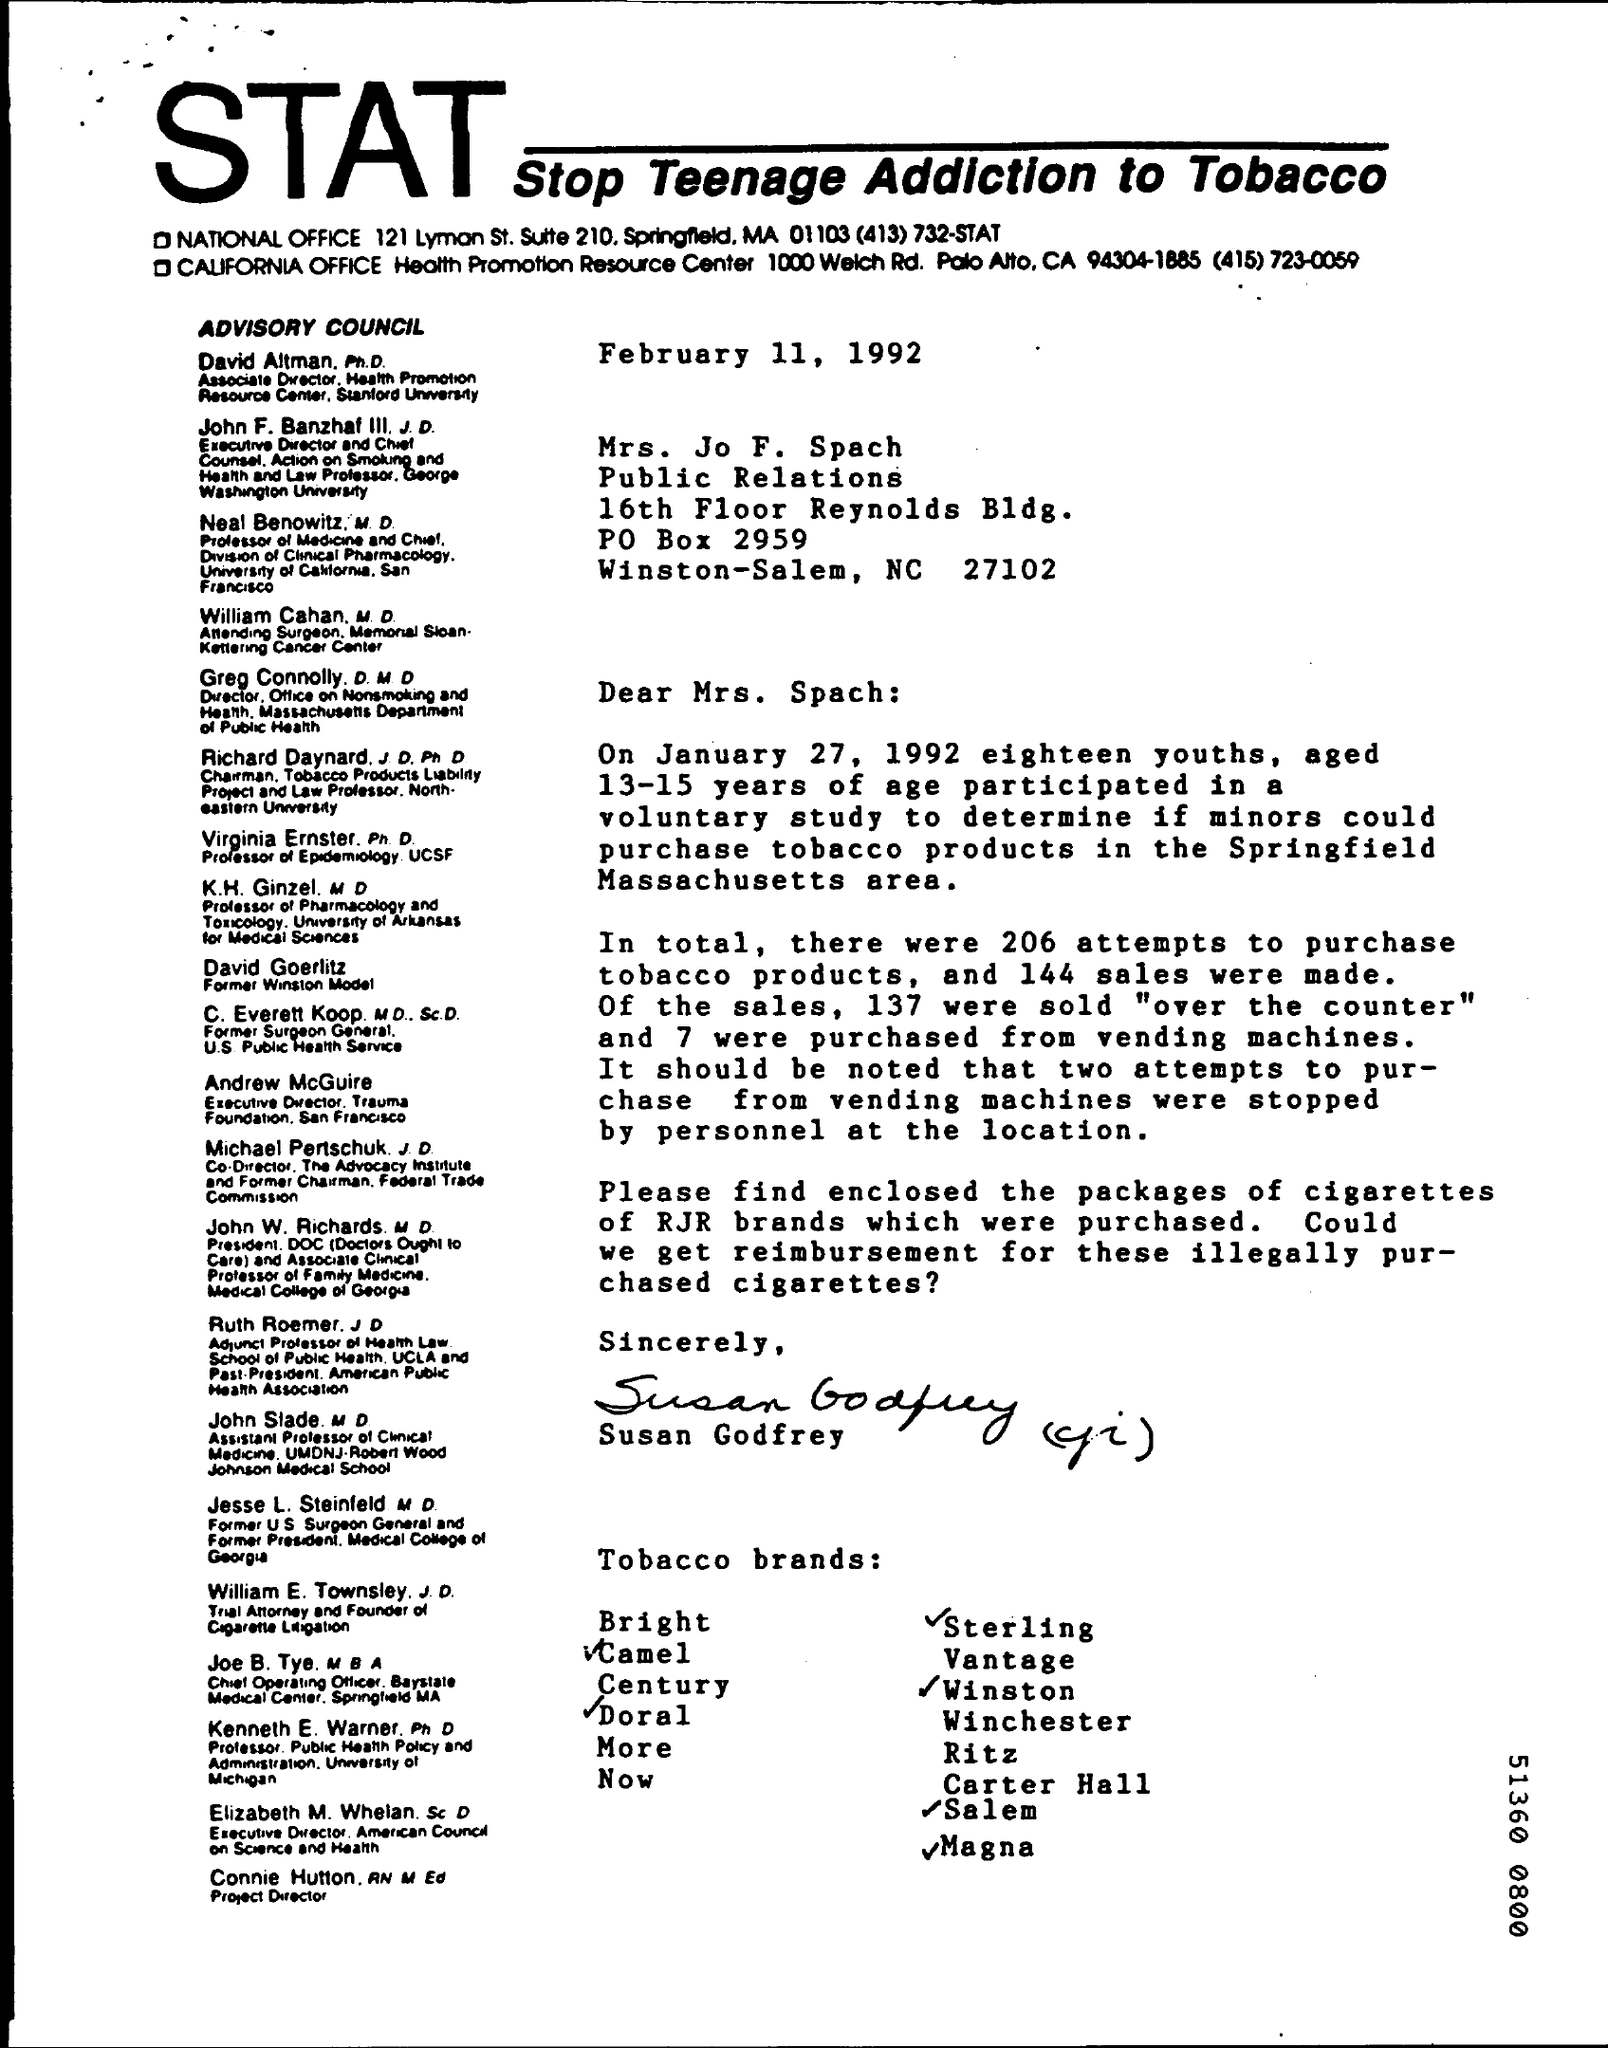Highlight a few significant elements in this photo. The acronym STAT stands for "Stop Teenage Addiction to Tobacco", a campaign aimed at reducing the prevalence of tobacco addiction among young people. The letter is dated February 11, 1992. The letter is addressed to Mrs. Jo F. Spach. 